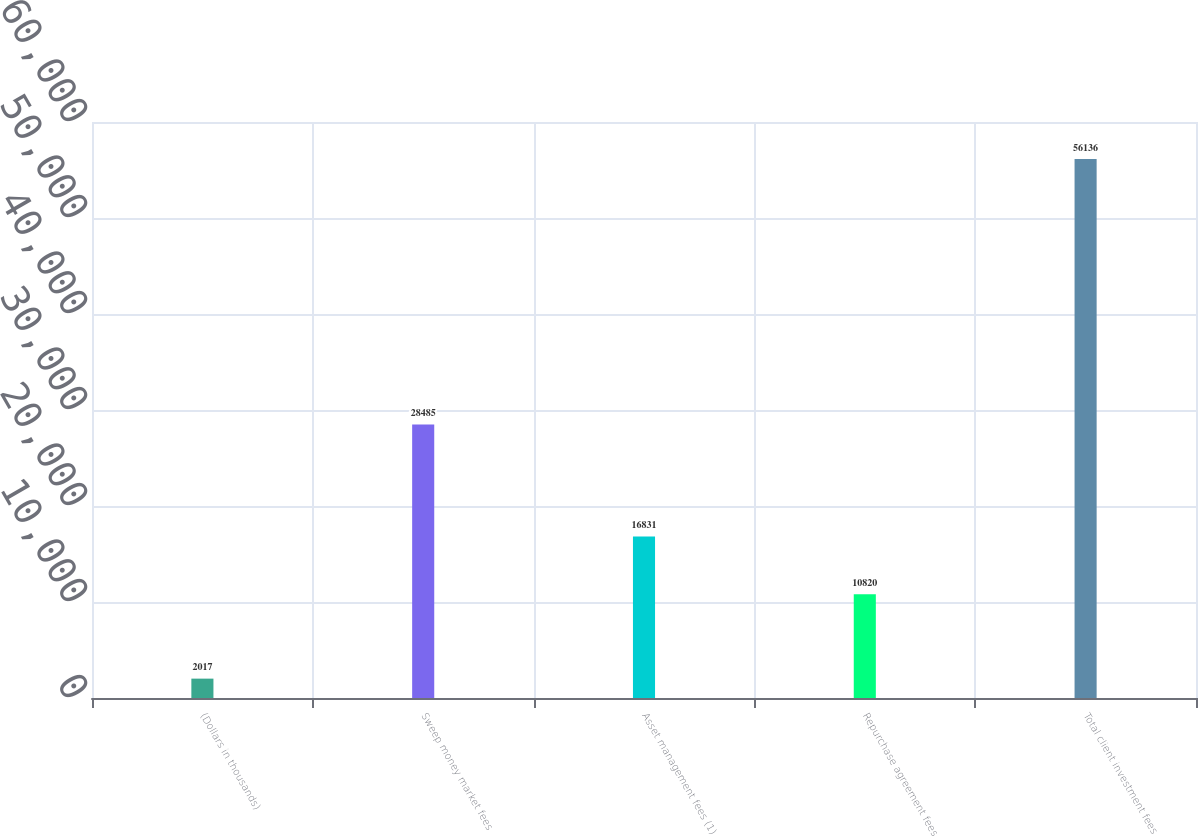<chart> <loc_0><loc_0><loc_500><loc_500><bar_chart><fcel>(Dollars in thousands)<fcel>Sweep money market fees<fcel>Asset management fees (1)<fcel>Repurchase agreement fees<fcel>Total client investment fees<nl><fcel>2017<fcel>28485<fcel>16831<fcel>10820<fcel>56136<nl></chart> 